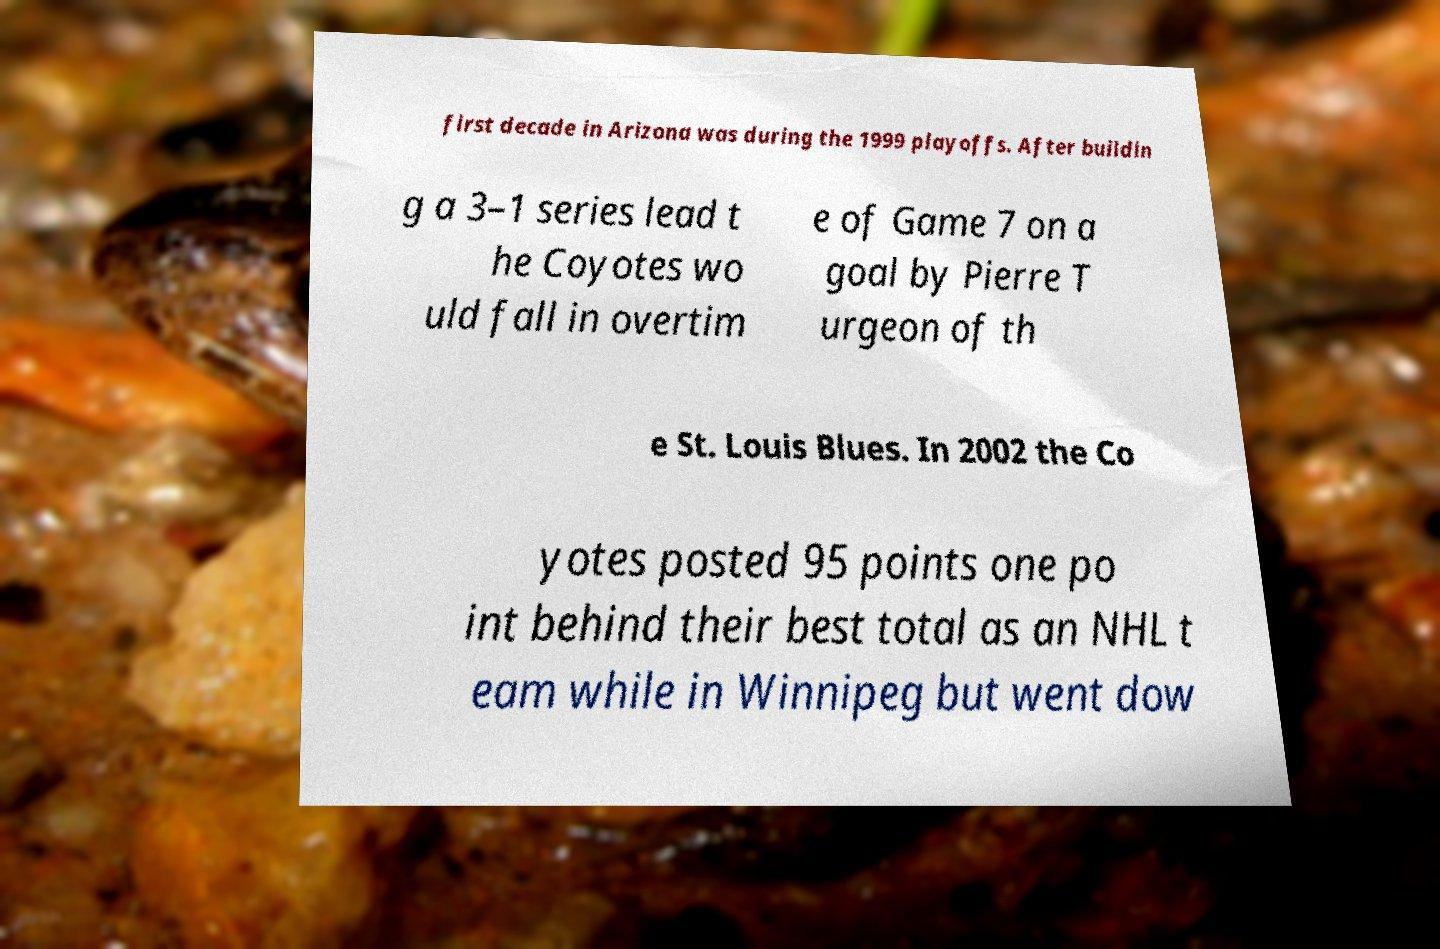Could you extract and type out the text from this image? first decade in Arizona was during the 1999 playoffs. After buildin g a 3–1 series lead t he Coyotes wo uld fall in overtim e of Game 7 on a goal by Pierre T urgeon of th e St. Louis Blues. In 2002 the Co yotes posted 95 points one po int behind their best total as an NHL t eam while in Winnipeg but went dow 